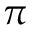Convert formula to latex. <formula><loc_0><loc_0><loc_500><loc_500>\pi</formula> 